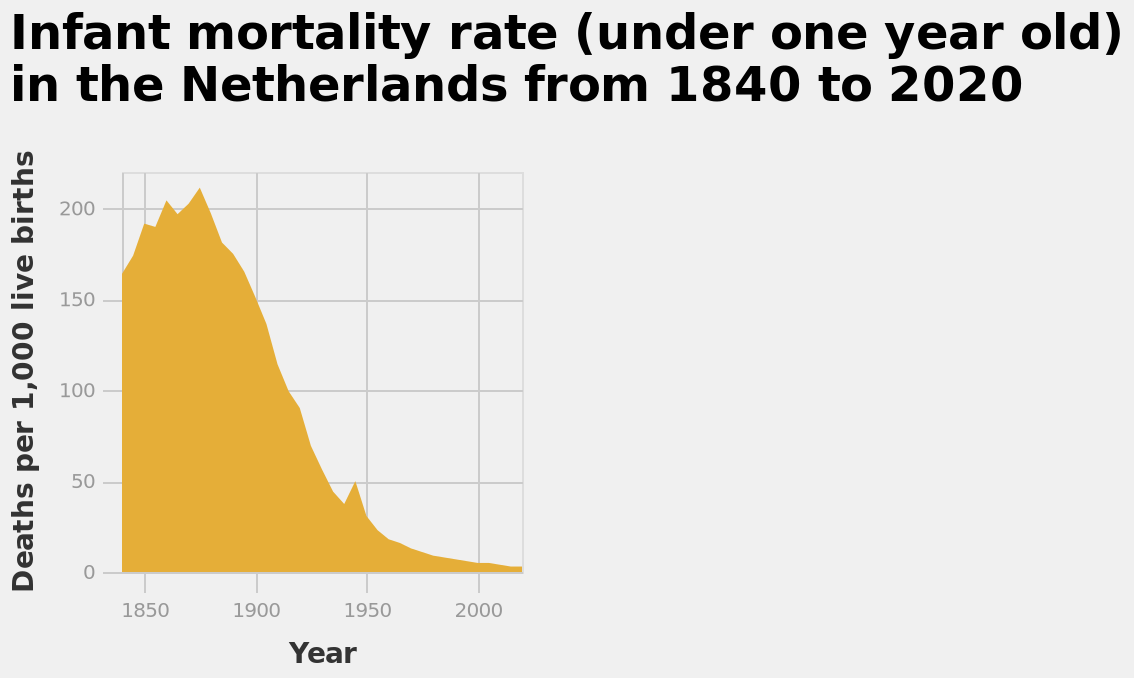<image>
What does the y-axis represent?  The y-axis represents the number of deaths per 1,000 live births, indicating the infant mortality rate in the Netherlands. Offer a thorough analysis of the image. Infant mortality rate in the Netherlands has significantly improved over the last century with rates around 200 times lower than at their peak. 